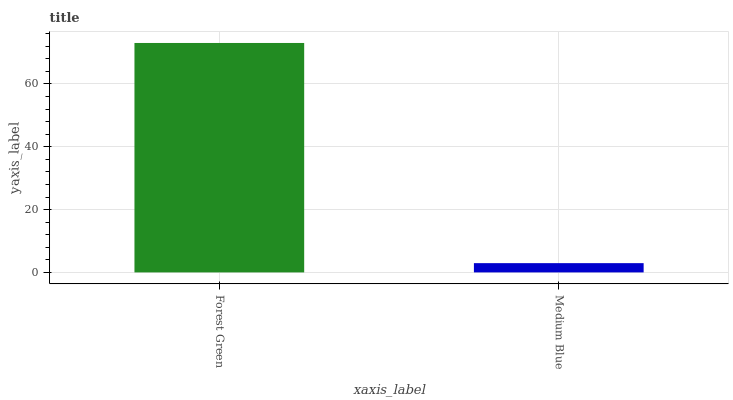Is Medium Blue the maximum?
Answer yes or no. No. Is Forest Green greater than Medium Blue?
Answer yes or no. Yes. Is Medium Blue less than Forest Green?
Answer yes or no. Yes. Is Medium Blue greater than Forest Green?
Answer yes or no. No. Is Forest Green less than Medium Blue?
Answer yes or no. No. Is Forest Green the high median?
Answer yes or no. Yes. Is Medium Blue the low median?
Answer yes or no. Yes. Is Medium Blue the high median?
Answer yes or no. No. Is Forest Green the low median?
Answer yes or no. No. 